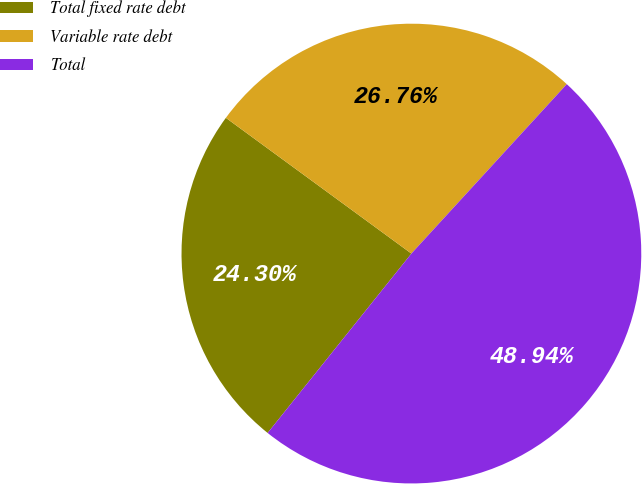Convert chart to OTSL. <chart><loc_0><loc_0><loc_500><loc_500><pie_chart><fcel>Total fixed rate debt<fcel>Variable rate debt<fcel>Total<nl><fcel>24.3%<fcel>26.76%<fcel>48.94%<nl></chart> 